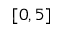Convert formula to latex. <formula><loc_0><loc_0><loc_500><loc_500>[ 0 , 5 ]</formula> 